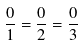Convert formula to latex. <formula><loc_0><loc_0><loc_500><loc_500>\frac { 0 } { 1 } = \frac { 0 } { 2 } = \frac { 0 } { 3 }</formula> 